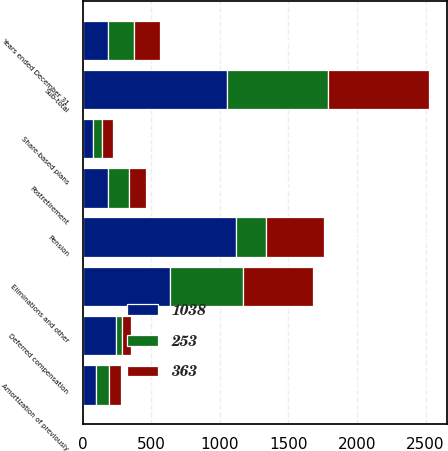Convert chart to OTSL. <chart><loc_0><loc_0><loc_500><loc_500><stacked_bar_chart><ecel><fcel>Years ended December 31<fcel>Share-based plans<fcel>Deferred compensation<fcel>Amortization of previously<fcel>Eliminations and other<fcel>Sub-total<fcel>Pension<fcel>Postretirement<nl><fcel>1038<fcel>188<fcel>77<fcel>240<fcel>98<fcel>640<fcel>1055<fcel>1120<fcel>188<nl><fcel>253<fcel>188<fcel>66<fcel>46<fcel>94<fcel>527<fcel>733<fcel>217<fcel>153<nl><fcel>363<fcel>188<fcel>76<fcel>63<fcel>90<fcel>511<fcel>740<fcel>421<fcel>123<nl></chart> 